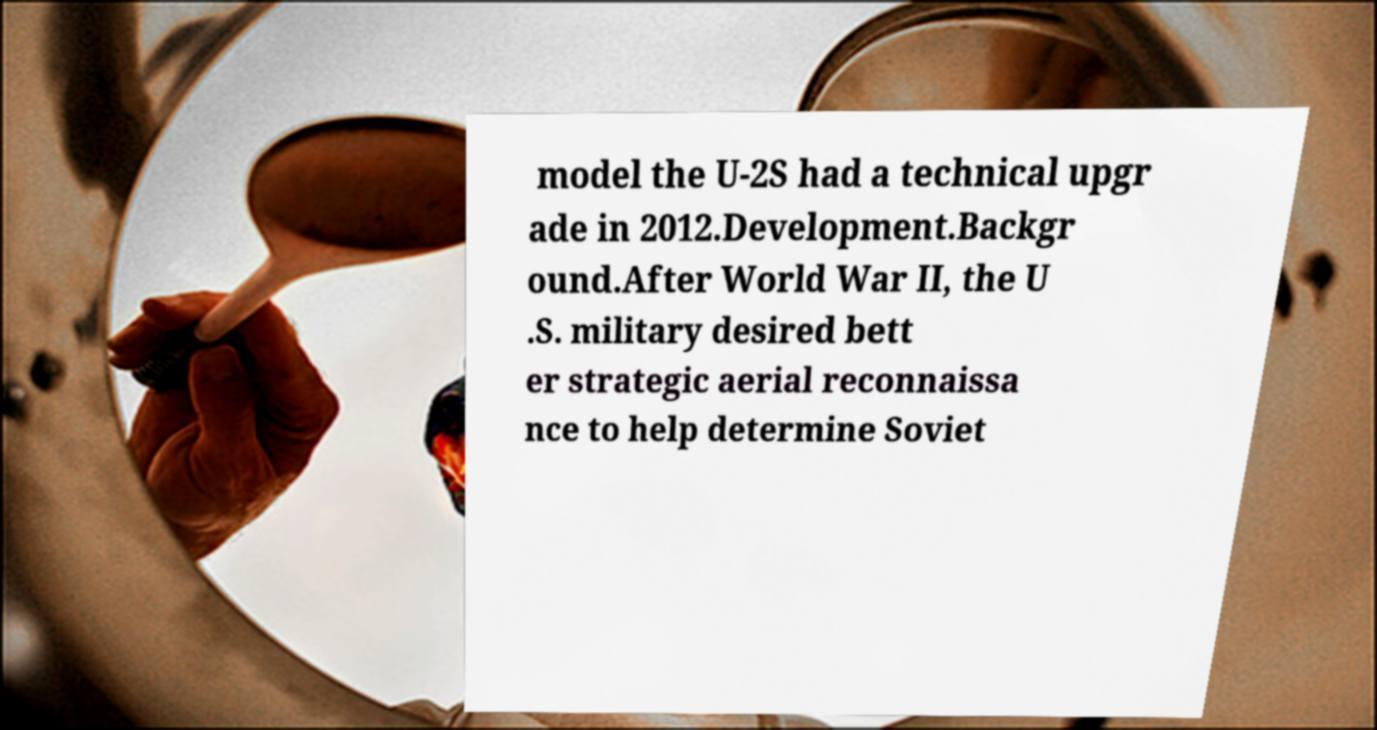For documentation purposes, I need the text within this image transcribed. Could you provide that? model the U-2S had a technical upgr ade in 2012.Development.Backgr ound.After World War II, the U .S. military desired bett er strategic aerial reconnaissa nce to help determine Soviet 